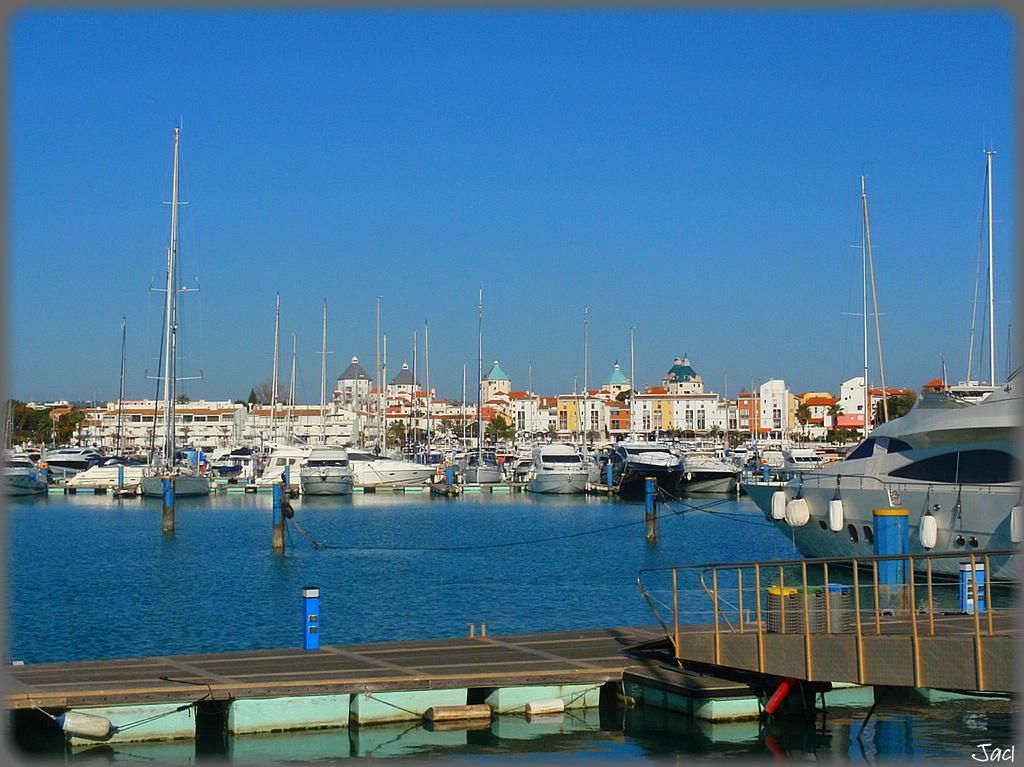What type of vehicles can be seen on the water in the image? There are ships on the water in the image. What structure connects the two sides in the image? There is a bridge in the image. What can be seen in the distance in the image? There are buildings in the background of the image. What is visible at the top of the image? The sky is visible at the top of the image. What type of toothbrush is being used by the committee in the image? There is no toothbrush or committee present in the image. What color is the chalk used to draw on the bridge in the image? There is no chalk or drawing on the bridge in the image. 